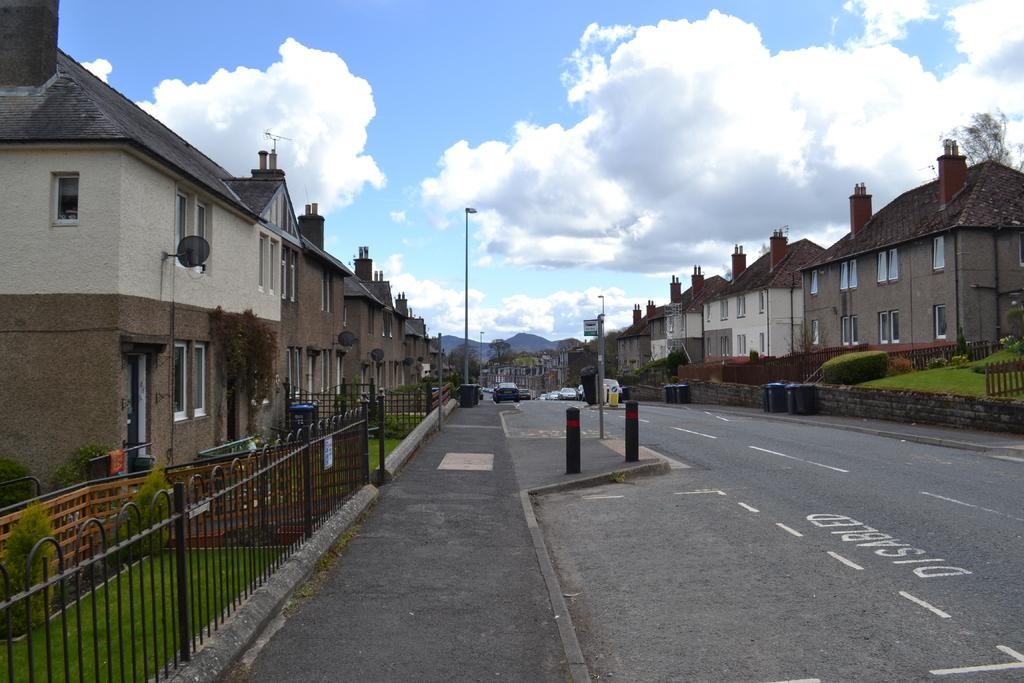What type of structures can be seen in the image? There are iron grills, a fence, and buildings in the image. What type of vegetation is present in the image? There is grass, plants, and trees in the image. What type of man-made objects can be seen in the image? There are poles, lights, boards, and vehicles on the road in the image. What natural features can be seen in the image? There are hills in the image. What is visible in the background of the image? The sky is visible in the background of the image. What historical event is being commemorated by the iron grills in the image? The iron grills in the image are not commemorating any historical event; they are simply a type of structure. What invention is being used to illuminate the area in the image? The lights in the image are not an invention; they are simply a type of object used for illumination. 